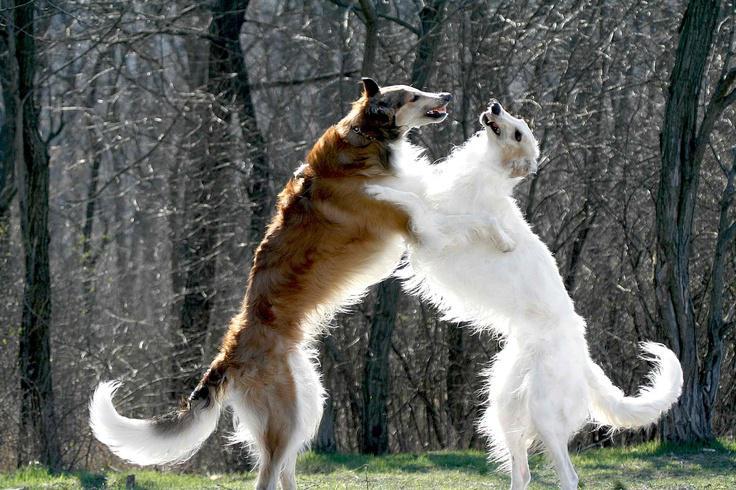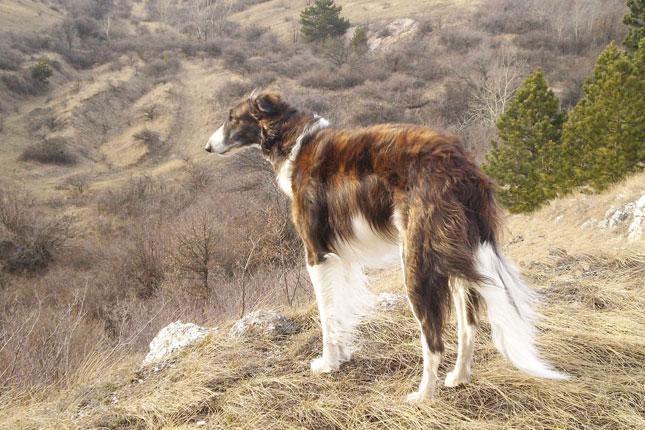The first image is the image on the left, the second image is the image on the right. Assess this claim about the two images: "There are two dogs in the image pair, both facing right.". Correct or not? Answer yes or no. No. The first image is the image on the left, the second image is the image on the right. Examine the images to the left and right. Is the description "One dog is standing on all fours, and at least one dog has its head raised distinctly upward." accurate? Answer yes or no. Yes. 